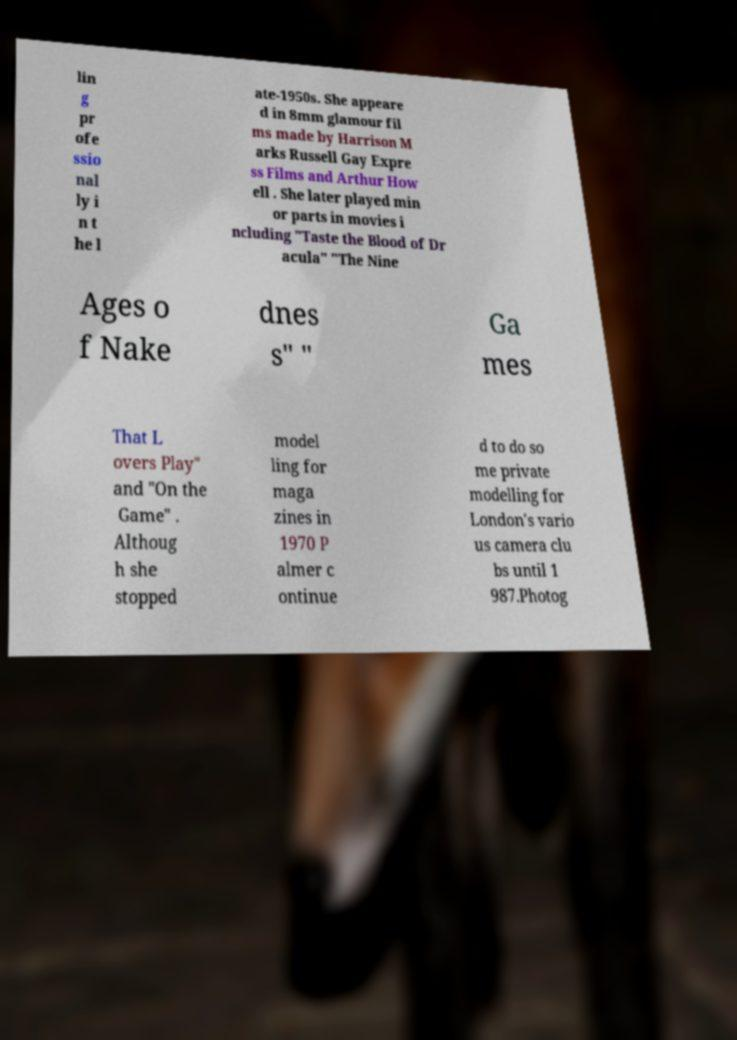Please identify and transcribe the text found in this image. lin g pr ofe ssio nal ly i n t he l ate-1950s. She appeare d in 8mm glamour fil ms made by Harrison M arks Russell Gay Expre ss Films and Arthur How ell . She later played min or parts in movies i ncluding "Taste the Blood of Dr acula" "The Nine Ages o f Nake dnes s" " Ga mes That L overs Play" and "On the Game" . Althoug h she stopped model ling for maga zines in 1970 P almer c ontinue d to do so me private modelling for London's vario us camera clu bs until 1 987.Photog 